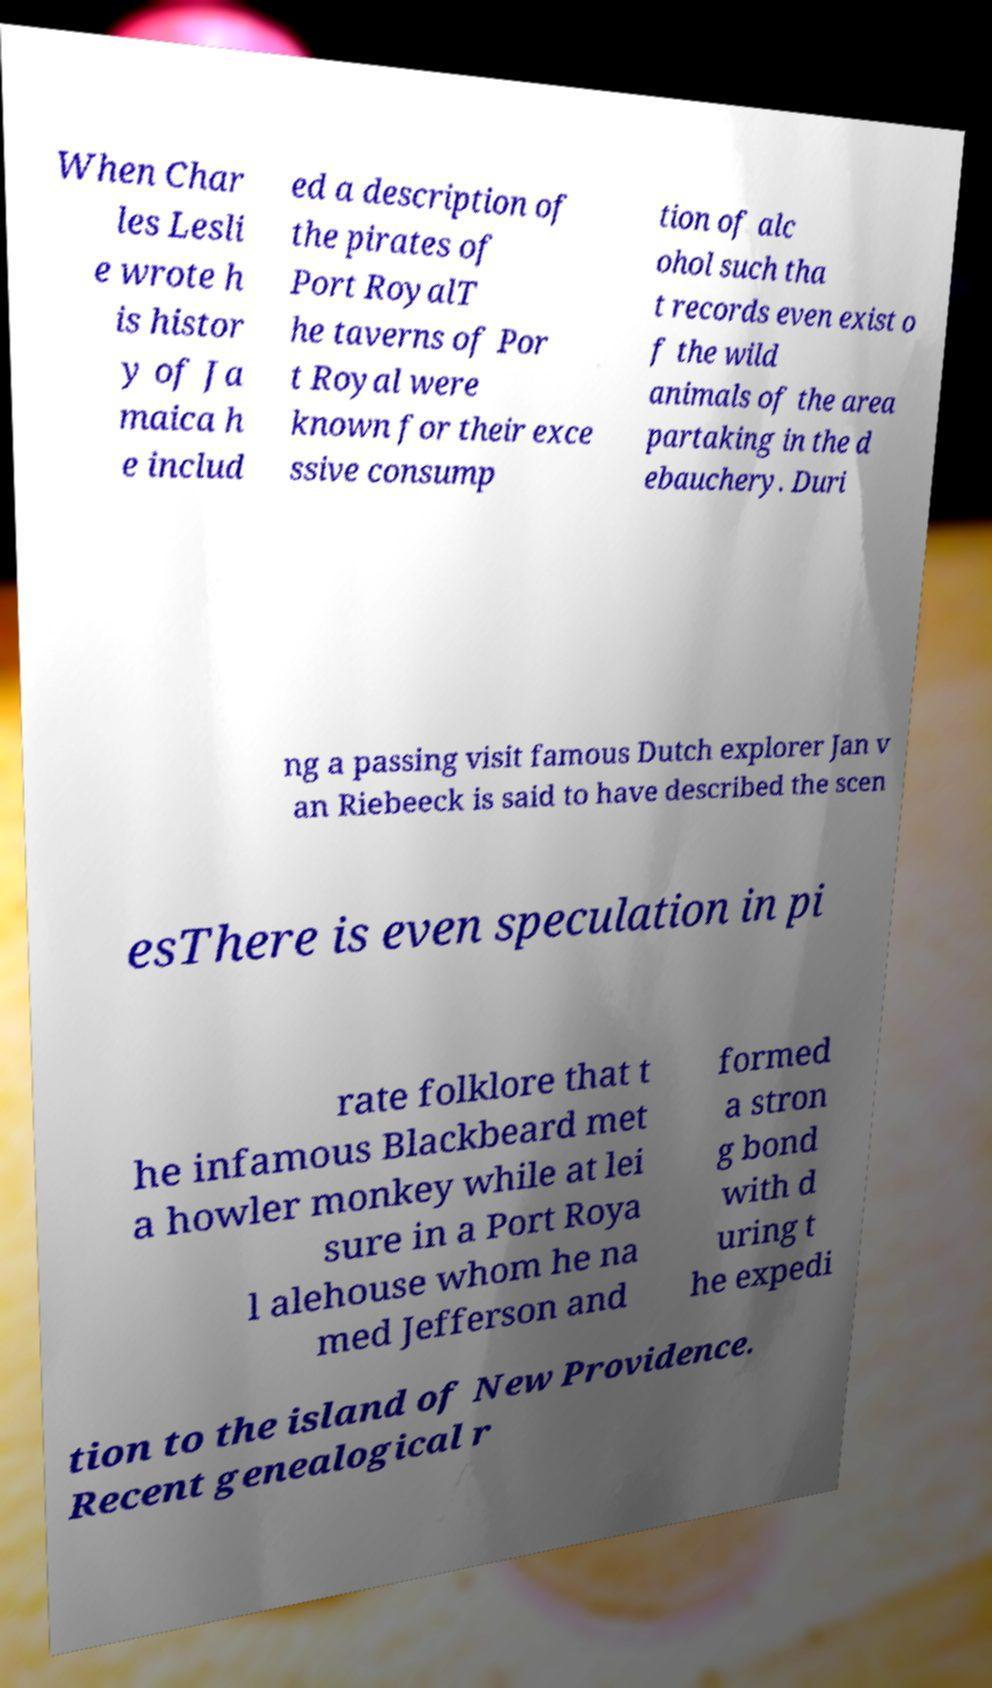For documentation purposes, I need the text within this image transcribed. Could you provide that? When Char les Lesli e wrote h is histor y of Ja maica h e includ ed a description of the pirates of Port RoyalT he taverns of Por t Royal were known for their exce ssive consump tion of alc ohol such tha t records even exist o f the wild animals of the area partaking in the d ebauchery. Duri ng a passing visit famous Dutch explorer Jan v an Riebeeck is said to have described the scen esThere is even speculation in pi rate folklore that t he infamous Blackbeard met a howler monkey while at lei sure in a Port Roya l alehouse whom he na med Jefferson and formed a stron g bond with d uring t he expedi tion to the island of New Providence. Recent genealogical r 